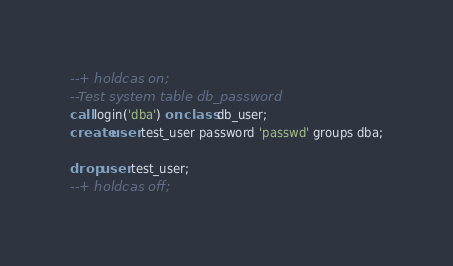<code> <loc_0><loc_0><loc_500><loc_500><_SQL_>--+ holdcas on;
--Test system table db_password
call login('dba') on class db_user;
create user test_user password 'passwd' groups dba;

drop user test_user;
--+ holdcas off;
</code> 